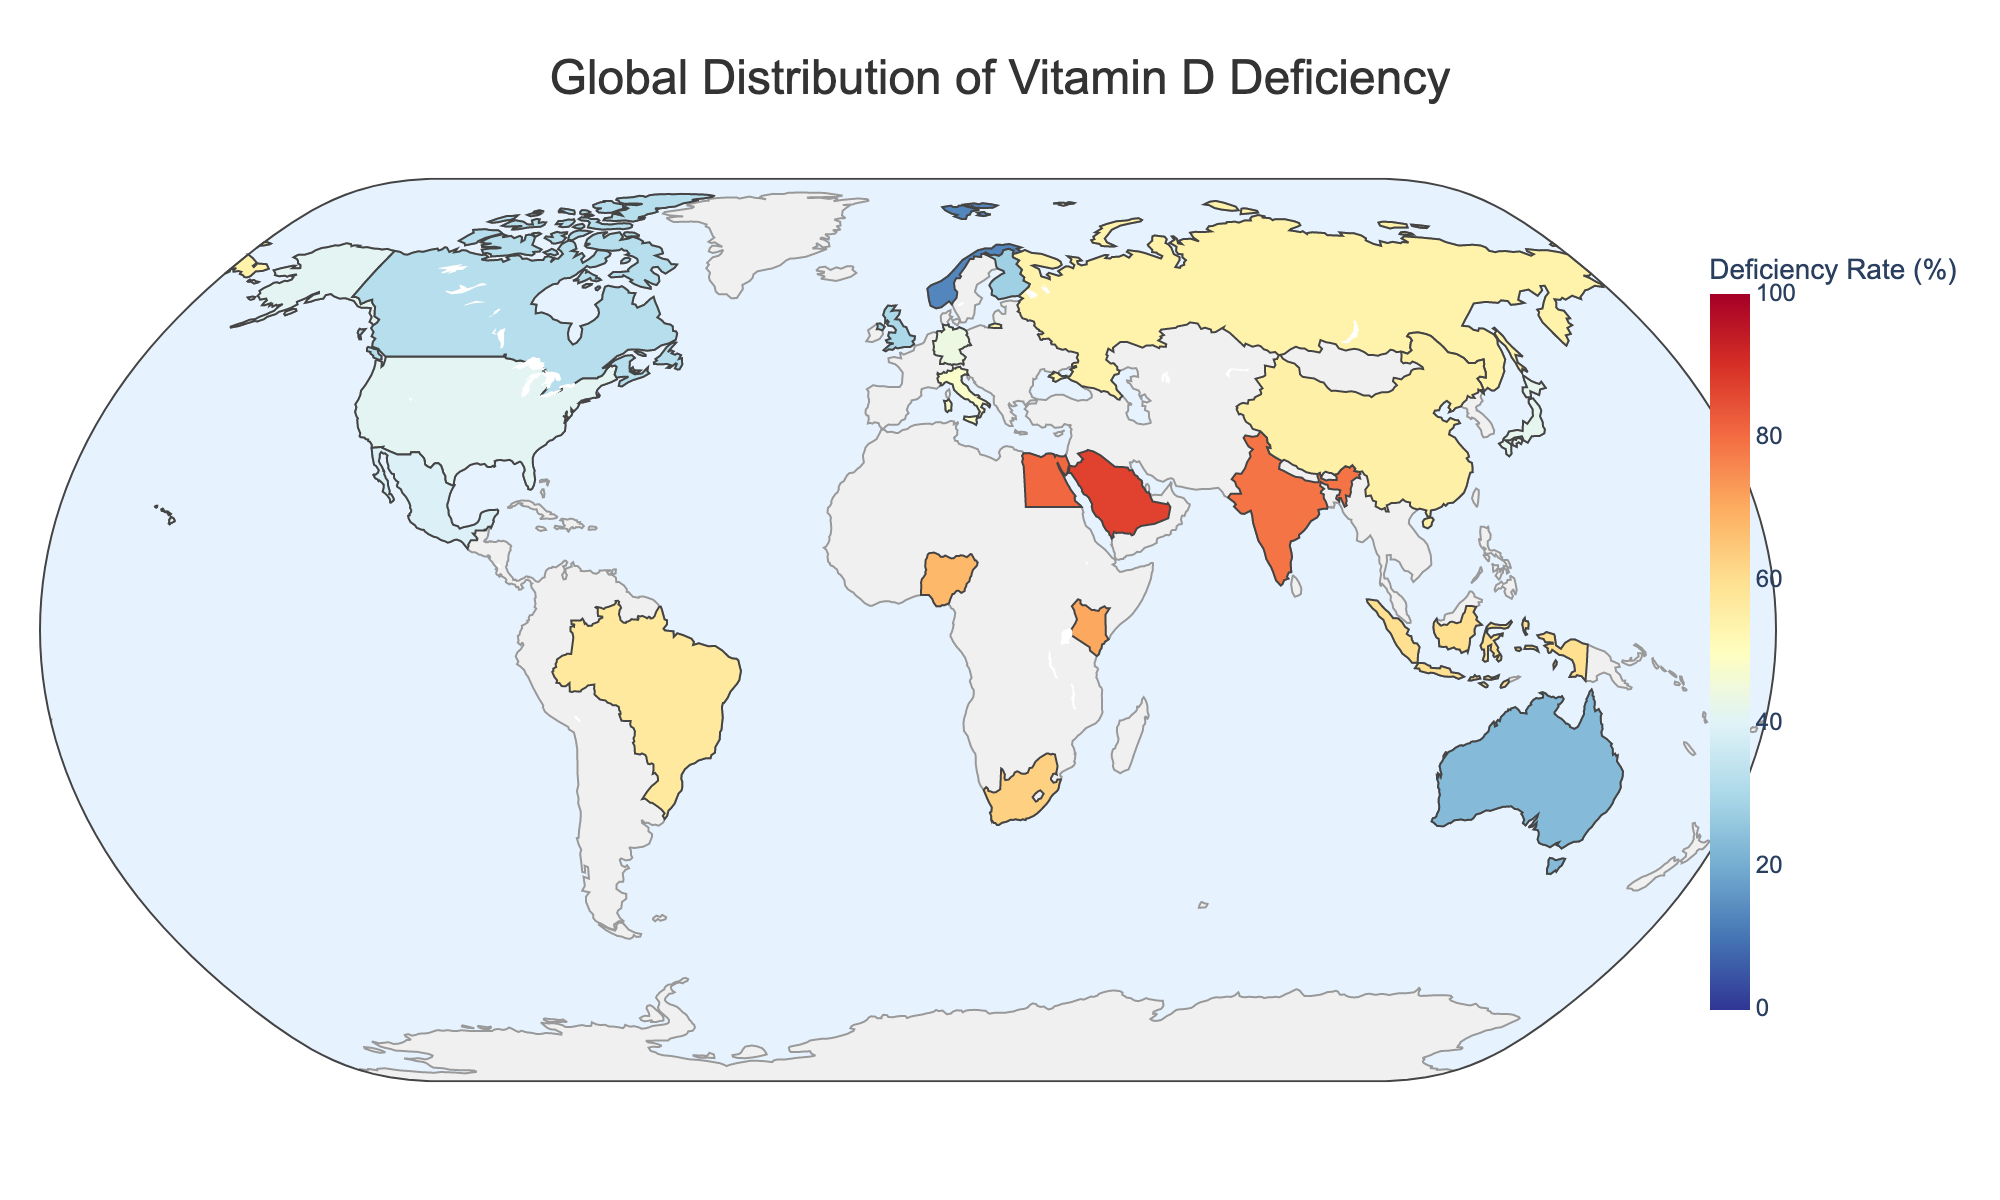What's the title of the geographic plot? The title is usually located at the top of the figure. Refer to the very top part of your plot to find the title.
Answer: Global Distribution of Vitamin D Deficiency Which region has the country with the highest rate of vitamin D deficiency? To determine this, look for the country with the darkest color (indicating the highest rate) and then check the associated region.
Answer: Middle East What's the average vitamin D deficiency rate of countries in Northern Europe? Identify the countries in Northern Europe from the data, and then calculate the average of their rates. Norway (13), Finland (28), United Kingdom (30). The sum is 13 + 28 + 30 = 71. There are 3 countries, so the average is 71/3.
Answer: 23.67 Is Brazil or India more affected by vitamin D deficiency? Compare the vitamin D deficiency rates between Brazil (57) and India (79).
Answer: India Which country has the lowest rate of vitamin D deficiency, and what is it? Find the country with the lightest color, indicating the lowest deficiency rate, and read the specific percentage.
Answer: Norway, 13 How many countries have a vitamin D deficiency rate above 50%? Count the number of countries with a deficiency rate higher than 50%: Saudi Arabia (87), Brazil (57), South Africa (63), India (79), Nigeria (68), Egypt (81), China (55), Kenya (71), Indonesia (60).
Answer: 9 Which country in Eastern Europe has data presented in this figure? Look for the country listed under the Eastern Europe region in the data.
Answer: Russia Compare the vitamin D deficiency rates between countries in East Asia. Which one is higher? Identify the countries in East Asia from the data and compare their rates. Japan (42), China (55).
Answer: China Which region appears to have the most consistently high vitamin D deficiency rates? Observe the regions and note the one where multiple countries have high deficiency rates. The Middle East and parts of Africa show consistently high rates, but since the Middle East has the highest recorded rate, it stands out.
Answer: Middle East 